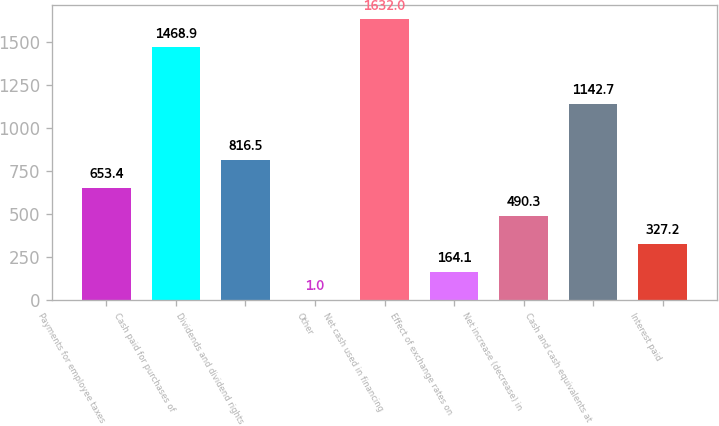Convert chart. <chart><loc_0><loc_0><loc_500><loc_500><bar_chart><fcel>Payments for employee taxes<fcel>Cash paid for purchases of<fcel>Dividends and dividend rights<fcel>Other<fcel>Net cash used in financing<fcel>Effect of exchange rates on<fcel>Net increase (decrease) in<fcel>Cash and cash equivalents at<fcel>Interest paid<nl><fcel>653.4<fcel>1468.9<fcel>816.5<fcel>1<fcel>1632<fcel>164.1<fcel>490.3<fcel>1142.7<fcel>327.2<nl></chart> 